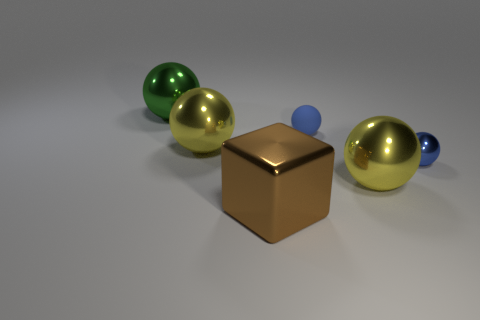Are there any other things that have the same shape as the brown thing?
Your answer should be very brief. No. Is there any other thing that has the same material as the green ball?
Provide a succinct answer. Yes. What is the size of the green metal thing?
Provide a short and direct response. Large. What color is the ball that is behind the tiny metal object and to the right of the brown metallic block?
Give a very brief answer. Blue. Is the number of tiny rubber objects greater than the number of blue metal cubes?
Provide a succinct answer. Yes. How many things are brown cylinders or blue matte things that are behind the block?
Your answer should be compact. 1. Is the blue matte sphere the same size as the brown metal object?
Ensure brevity in your answer.  No. Are there any yellow metallic things on the left side of the brown cube?
Provide a succinct answer. Yes. What size is the shiny ball that is on the left side of the big block and in front of the large green ball?
Offer a very short reply. Large. What number of things are either matte balls or big green metal objects?
Make the answer very short. 2. 